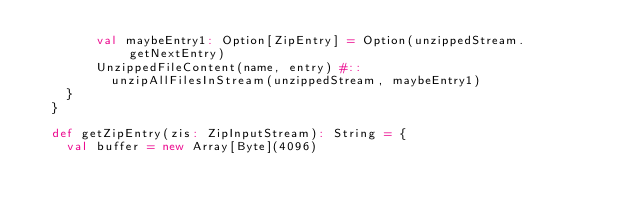<code> <loc_0><loc_0><loc_500><loc_500><_Scala_>        val maybeEntry1: Option[ZipEntry] = Option(unzippedStream.getNextEntry)
        UnzippedFileContent(name, entry) #::
          unzipAllFilesInStream(unzippedStream, maybeEntry1)
    }
  }

  def getZipEntry(zis: ZipInputStream): String = {
    val buffer = new Array[Byte](4096)</code> 